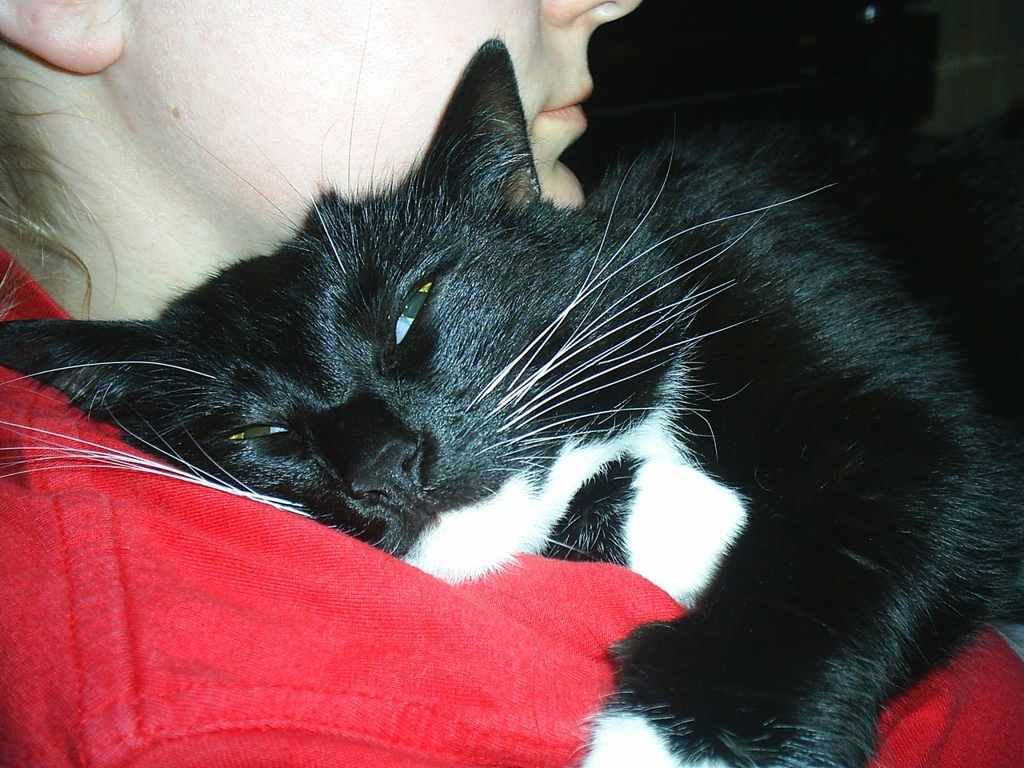Can you give me some tips on how to make a cat comfortable like the one in the picture? Certainly! To make a cat comfortable, you can start by providing a calm and quiet environment. Gentle petting, especially in areas where cats like to be touched such as under their chin or along their back, can help them relax. Also, creating a cozy space with familiar scents and a comfortable temperature is key. Be patient and let the cat approach you on its terms, showing that you're a trustworthy companion. 